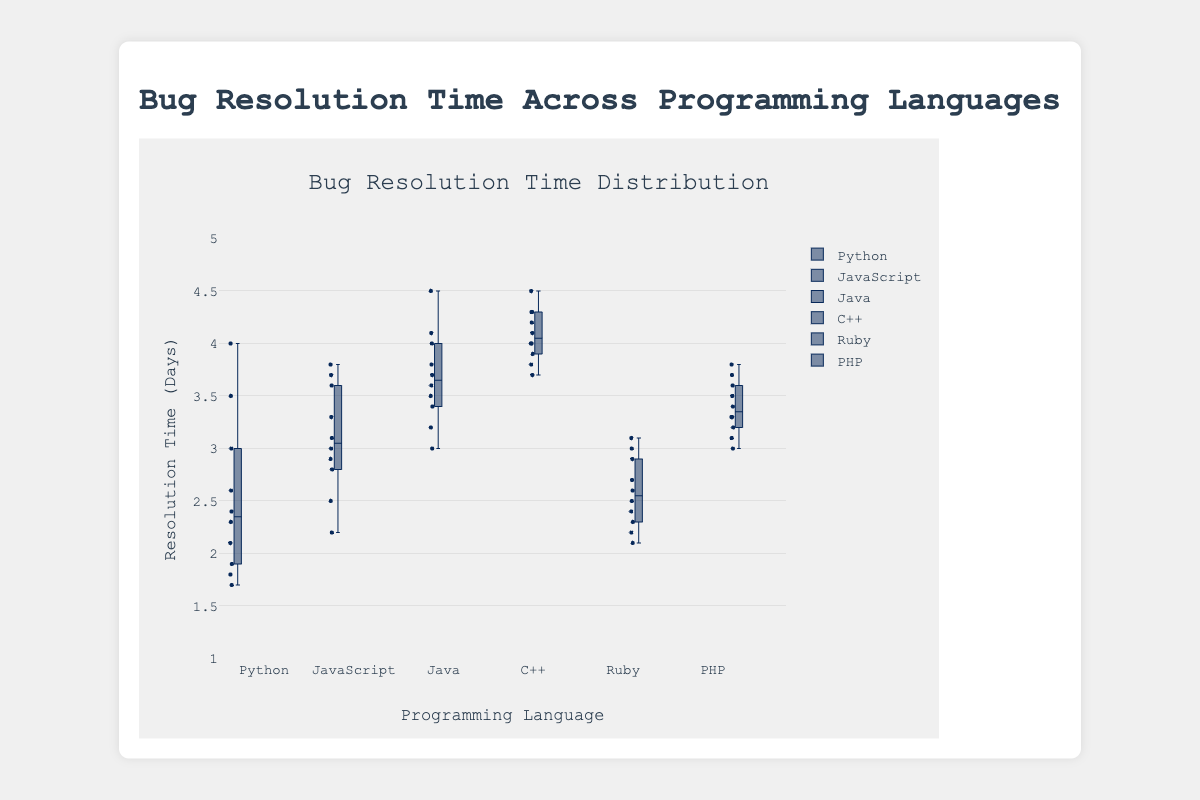What is the title of the box plot? The title of the box plot is displayed at the top of the figure. It is found within the text element set by the `title` field of the layout options.
Answer: Bug Resolution Time Across Programming Languages What is the range of resolution times displayed on the y-axis? The y-axis range defines the vertical span of resolution times and is visible on the left side of the plot. According to the layout, it ranges from 1 to 5 days.
Answer: 1 to 5 Which programming language has the lowest median bug resolution time? To find the median, look for the lines inside each box that represent the median values. The box labeled "Python" has the lowest position for its median line compared to the other languages.
Answer: Python Which programming language has the highest upper quartile range? The upper quartile range is represented by the top edge of the box. The box labeled "C++" has the highest top edge compared to others, indicating the largest upper quartile range.
Answer: C++ What is the interquartile range for JavaScript bugs? The interquartile range (IQR) is the difference between the upper quartile (top edge of the box) and the lower quartile (bottom edge of the box). For JavaScript: Q3 (3.8) - Q1 (2.8) = 1.0
Answer: 1.0 Which programming languages have any outliers, and what are they? Outliers are points that lie outside the whiskers of the box plots. By observation, there are no outliers present for any of the programming languages in the displayed box plot.
Answer: None Which programming language has the smallest variability in bug resolution times? Variability is reflected by the height of the box (interquartile range). The Ruby box plot has the shortest height, indicating the smallest variability.
Answer: Ruby How does the median bug resolution time for PHP compare to that of Java? Compare the median lines within each box plot. The median for PHP is lower than that for Java.
Answer: PHP's median is lower What is the difference between the median resolution times of Python and C++? To find the difference, subtract the median value of Python from that of C++. Median for C++ (4.0) - Median for Python (2.4). The difference is 1.6 days.
Answer: 1.6 days 